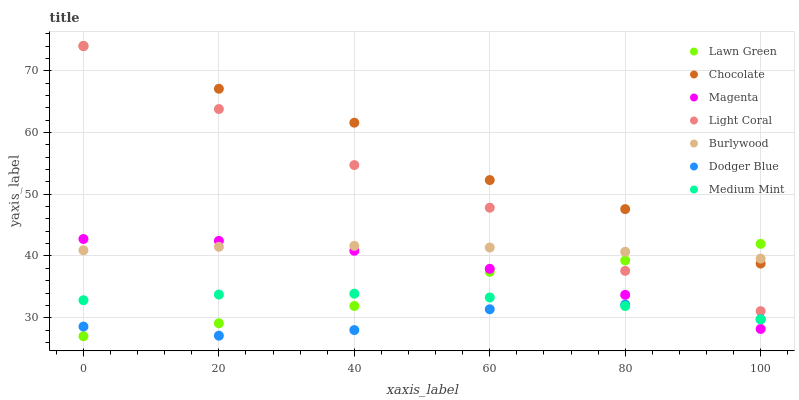Does Dodger Blue have the minimum area under the curve?
Answer yes or no. Yes. Does Chocolate have the maximum area under the curve?
Answer yes or no. Yes. Does Lawn Green have the minimum area under the curve?
Answer yes or no. No. Does Lawn Green have the maximum area under the curve?
Answer yes or no. No. Is Burlywood the smoothest?
Answer yes or no. Yes. Is Chocolate the roughest?
Answer yes or no. Yes. Is Lawn Green the smoothest?
Answer yes or no. No. Is Lawn Green the roughest?
Answer yes or no. No. Does Lawn Green have the lowest value?
Answer yes or no. Yes. Does Burlywood have the lowest value?
Answer yes or no. No. Does Light Coral have the highest value?
Answer yes or no. Yes. Does Lawn Green have the highest value?
Answer yes or no. No. Is Medium Mint less than Chocolate?
Answer yes or no. Yes. Is Light Coral greater than Magenta?
Answer yes or no. Yes. Does Burlywood intersect Chocolate?
Answer yes or no. Yes. Is Burlywood less than Chocolate?
Answer yes or no. No. Is Burlywood greater than Chocolate?
Answer yes or no. No. Does Medium Mint intersect Chocolate?
Answer yes or no. No. 